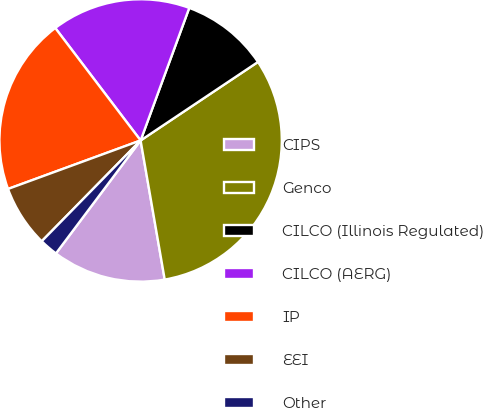<chart> <loc_0><loc_0><loc_500><loc_500><pie_chart><fcel>CIPS<fcel>Genco<fcel>CILCO (Illinois Regulated)<fcel>CILCO (AERG)<fcel>IP<fcel>EEI<fcel>Other<nl><fcel>12.97%<fcel>31.65%<fcel>10.02%<fcel>15.93%<fcel>20.25%<fcel>7.07%<fcel>2.11%<nl></chart> 